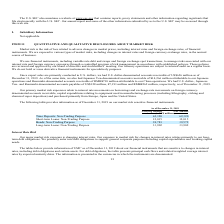According to United Micro Electronics's financial document, What is market risk? Market risk is the risk of loss related to adverse changes in market prices, including interest rates and foreign exchange rates, of financial instruments.. The document states: "Market risk is the risk of loss related to adverse changes in market prices, including interest rates and foreign exchange rates, of financial instrum..." Also, What were the Time Deposits: Non-Trading Purpose carrying amount? According to the financial document, 62,320 (in millions). The relevant text states: "NT$ millions) Time Deposits: Non-Trading Purpose 62,320 62,320 Short-term Loans: Non-Trading Purpose 12,015 12,015 Bonds: Non-Trading Purpose 38,781 39,572..." Also, What were the accounts receivables in 2019? According to the financial document, US$626 million. The relevant text states: "ad U.S. dollar-denominated accounts receivable of US$626 million as of December 31, 2019. As of the same date, we also had Japanese Yen-denominated accounts receiva..." Also, can you calculate: What is the difference in Time Deposits: Non-Trading Purpose between Carrying Amount and Fair Amount? I cannot find a specific answer to this question in the financial document. Also, can you calculate: What is the difference between Bonds: Non-Trading Purpose Carrying Amount and Fair Amount? Based on the calculation: 38,781 - 39,572, the result is -791 (in millions). This is based on the information: "e 12,015 12,015 Bonds: Non-Trading Purpose 38,781 39,572 Long-term Loans: Non-Trading Purpose 33,902 33,902 Purpose 12,015 12,015 Bonds: Non-Trading Purpose 38,781 39,572 Long-term Loans: Non-Trading ..." The key data points involved are: 38,781, 39,572. Also, can you calculate: What is the percentage increase / (decrease) of the Long-term Loans: Non-Trading Purpose Carrying Amount versus the Fair Amount? I cannot find a specific answer to this question in the financial document. 